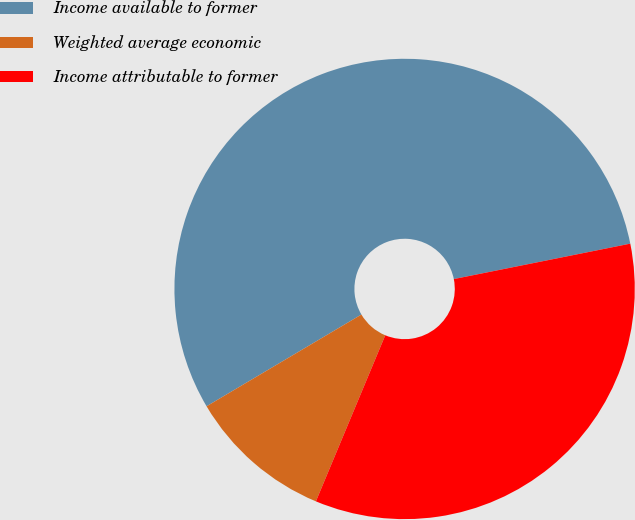Convert chart to OTSL. <chart><loc_0><loc_0><loc_500><loc_500><pie_chart><fcel>Income available to former<fcel>Weighted average economic<fcel>Income attributable to former<nl><fcel>55.36%<fcel>10.19%<fcel>34.45%<nl></chart> 